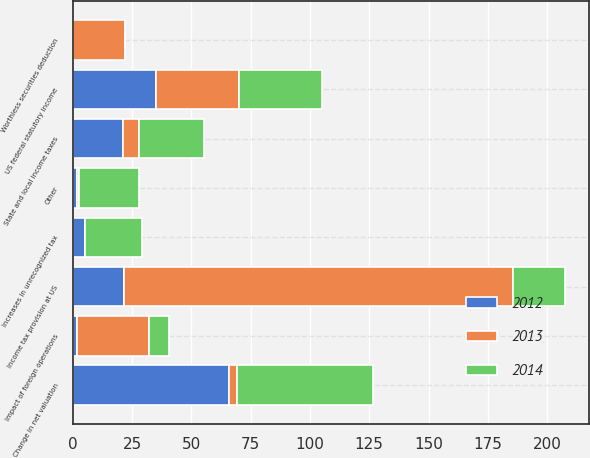<chart> <loc_0><loc_0><loc_500><loc_500><stacked_bar_chart><ecel><fcel>US federal statutory income<fcel>Income tax provision at US<fcel>State and local income taxes<fcel>Impact of foreign operations<fcel>Change in net valuation<fcel>Worthless securities deduction<fcel>Increases in unrecognized tax<fcel>Other<nl><fcel>2012<fcel>35<fcel>21.8<fcel>21.4<fcel>1.7<fcel>66<fcel>0<fcel>5.2<fcel>1.9<nl><fcel>2013<fcel>35<fcel>163.8<fcel>6.5<fcel>30.5<fcel>3.2<fcel>22.2<fcel>0<fcel>0.6<nl><fcel>2014<fcel>35<fcel>21.8<fcel>27.3<fcel>8.4<fcel>57.3<fcel>0<fcel>24.1<fcel>25.4<nl></chart> 